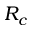Convert formula to latex. <formula><loc_0><loc_0><loc_500><loc_500>R _ { c }</formula> 